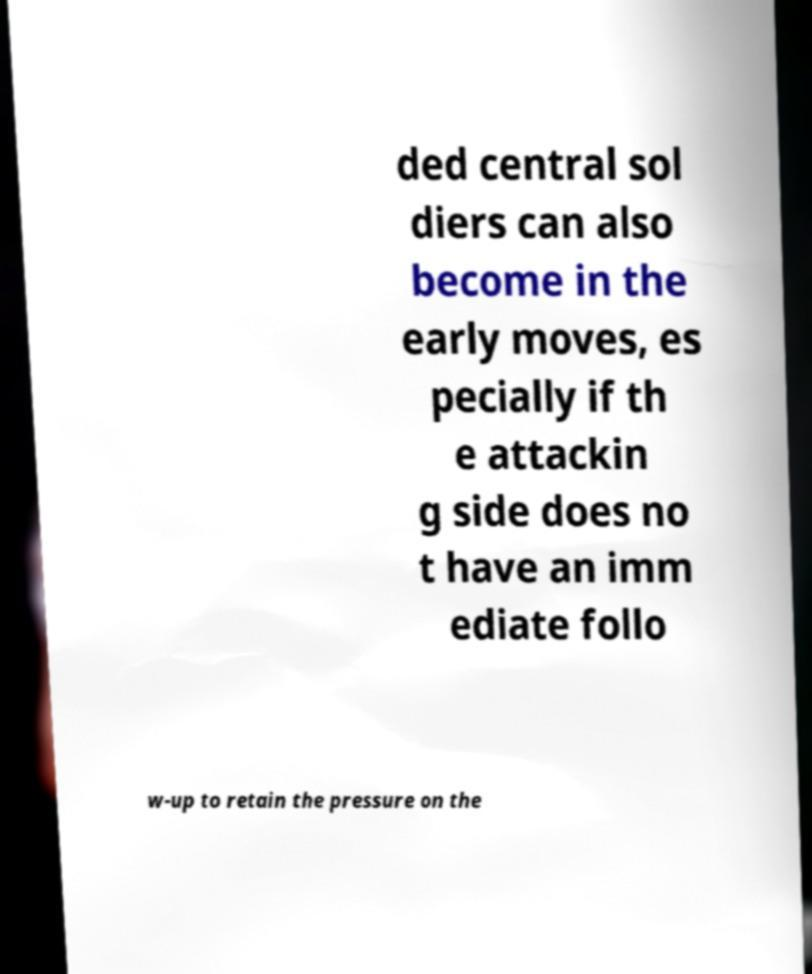Can you read and provide the text displayed in the image?This photo seems to have some interesting text. Can you extract and type it out for me? ded central sol diers can also become in the early moves, es pecially if th e attackin g side does no t have an imm ediate follo w-up to retain the pressure on the 